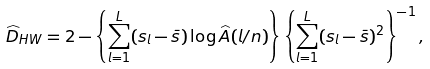<formula> <loc_0><loc_0><loc_500><loc_500>\widehat { D } _ { H W } = 2 - \left \{ \sum _ { l = 1 } ^ { L } ( s _ { l } - \bar { s } ) \log \widehat { A } ( l / n ) \right \} \left \{ \sum _ { l = 1 } ^ { L } ( s _ { l } - \bar { s } ) ^ { 2 } \right \} ^ { - 1 } ,</formula> 